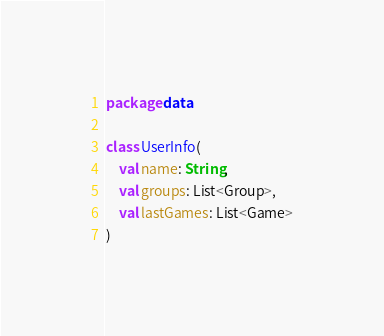<code> <loc_0><loc_0><loc_500><loc_500><_Kotlin_>package data

class UserInfo(
    val name: String,
    val groups: List<Group>,
    val lastGames: List<Game>
)
</code> 